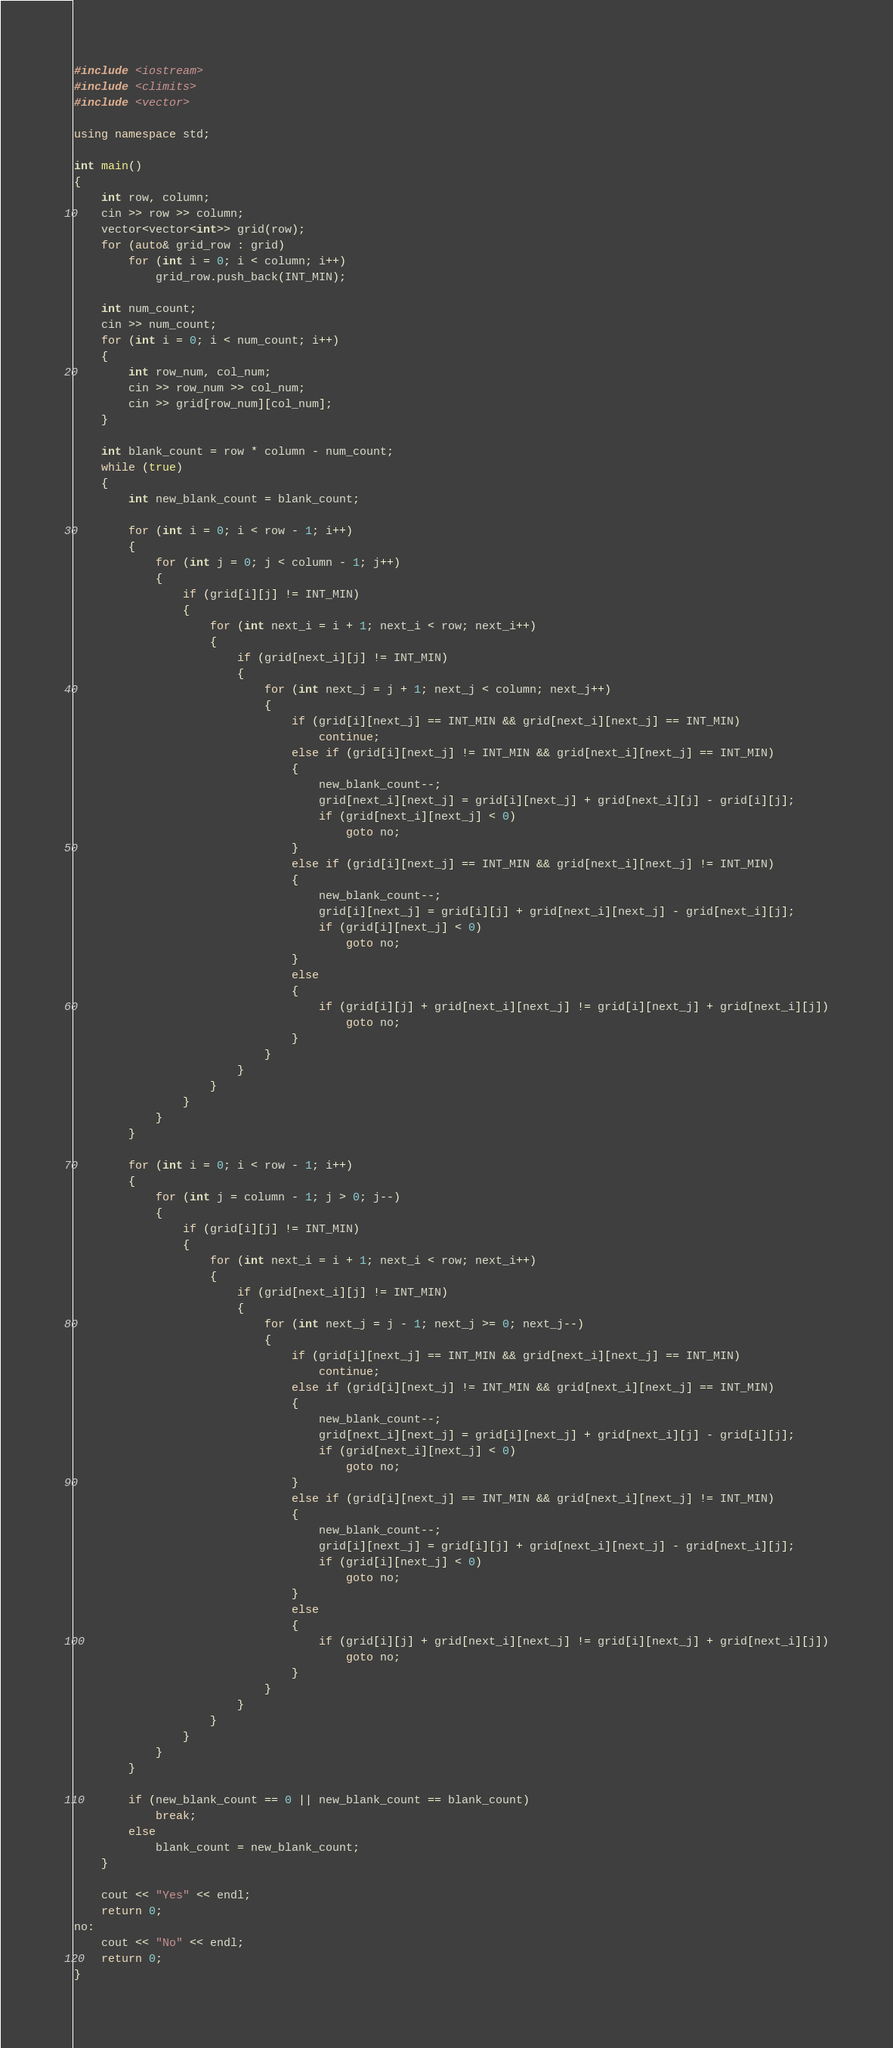<code> <loc_0><loc_0><loc_500><loc_500><_C++_>#include <iostream>
#include <climits>
#include <vector>

using namespace std;

int main()
{
	int row, column;
	cin >> row >> column;
	vector<vector<int>> grid(row);
	for (auto& grid_row : grid)
		for (int i = 0; i < column; i++)
			grid_row.push_back(INT_MIN);

	int num_count;
	cin >> num_count;
	for (int i = 0; i < num_count; i++)
	{
		int row_num, col_num;
		cin >> row_num >> col_num;
		cin >> grid[row_num][col_num];
	}

	int blank_count = row * column - num_count;
	while (true)
	{
		int new_blank_count = blank_count;

		for (int i = 0; i < row - 1; i++)
		{
			for (int j = 0; j < column - 1; j++)
			{
				if (grid[i][j] != INT_MIN)
				{
					for (int next_i = i + 1; next_i < row; next_i++)
					{
						if (grid[next_i][j] != INT_MIN)
						{
							for (int next_j = j + 1; next_j < column; next_j++)
							{
								if (grid[i][next_j] == INT_MIN && grid[next_i][next_j] == INT_MIN)
									continue;
								else if (grid[i][next_j] != INT_MIN && grid[next_i][next_j] == INT_MIN)
								{
									new_blank_count--;
									grid[next_i][next_j] = grid[i][next_j] + grid[next_i][j] - grid[i][j];
									if (grid[next_i][next_j] < 0)
										goto no;
								}
								else if (grid[i][next_j] == INT_MIN && grid[next_i][next_j] != INT_MIN)
								{
									new_blank_count--;
									grid[i][next_j] = grid[i][j] + grid[next_i][next_j] - grid[next_i][j];
									if (grid[i][next_j] < 0)
										goto no;
								}
								else
								{
									if (grid[i][j] + grid[next_i][next_j] != grid[i][next_j] + grid[next_i][j])
										goto no;
								}
							}
						}
					}
				}
			}
		}

		for (int i = 0; i < row - 1; i++)
		{
			for (int j = column - 1; j > 0; j--)
			{
				if (grid[i][j] != INT_MIN)
				{
					for (int next_i = i + 1; next_i < row; next_i++)
					{
						if (grid[next_i][j] != INT_MIN)
						{
							for (int next_j = j - 1; next_j >= 0; next_j--)
							{
								if (grid[i][next_j] == INT_MIN && grid[next_i][next_j] == INT_MIN)
									continue;
								else if (grid[i][next_j] != INT_MIN && grid[next_i][next_j] == INT_MIN)
								{
									new_blank_count--;
									grid[next_i][next_j] = grid[i][next_j] + grid[next_i][j] - grid[i][j];
									if (grid[next_i][next_j] < 0)
										goto no;
								}
								else if (grid[i][next_j] == INT_MIN && grid[next_i][next_j] != INT_MIN)
								{
									new_blank_count--;
									grid[i][next_j] = grid[i][j] + grid[next_i][next_j] - grid[next_i][j];
									if (grid[i][next_j] < 0)
										goto no;
								}
								else
								{
									if (grid[i][j] + grid[next_i][next_j] != grid[i][next_j] + grid[next_i][j])
										goto no;
								}
							}
						}
					}
				}
			}
		}

		if (new_blank_count == 0 || new_blank_count == blank_count)
			break;
		else
			blank_count = new_blank_count;
	}

	cout << "Yes" << endl;
	return 0;
no:
	cout << "No" << endl;
	return 0;
}</code> 